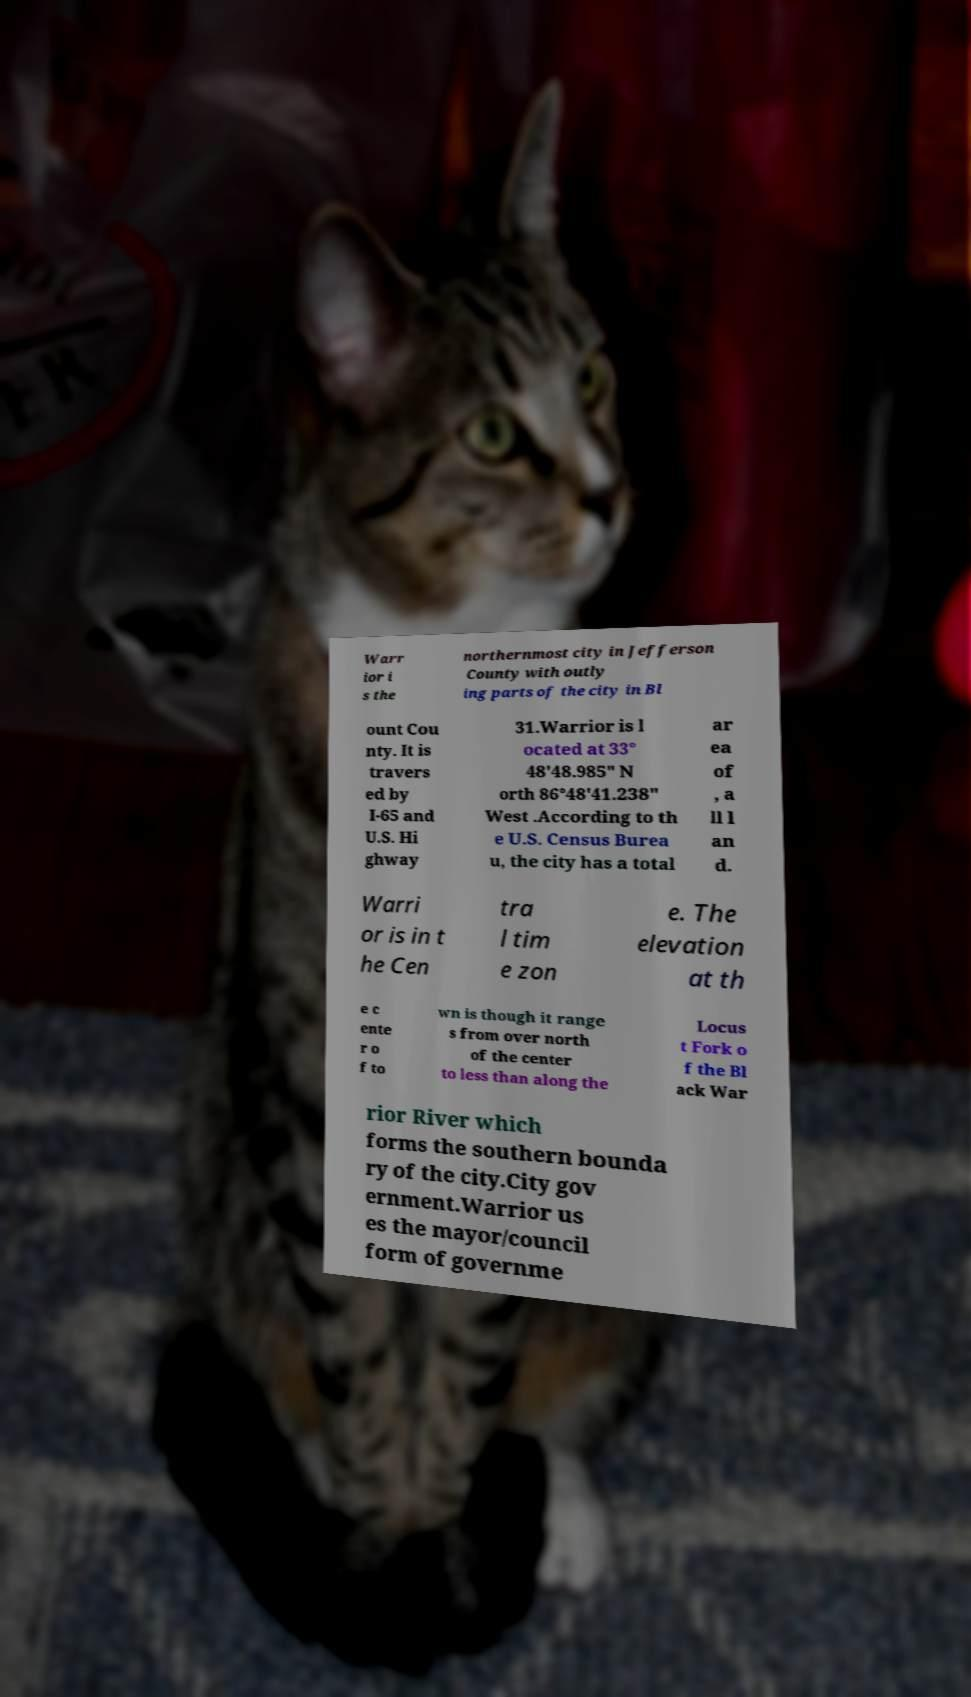I need the written content from this picture converted into text. Can you do that? Warr ior i s the northernmost city in Jefferson County with outly ing parts of the city in Bl ount Cou nty. It is travers ed by I-65 and U.S. Hi ghway 31.Warrior is l ocated at 33° 48'48.985" N orth 86°48'41.238" West .According to th e U.S. Census Burea u, the city has a total ar ea of , a ll l an d. Warri or is in t he Cen tra l tim e zon e. The elevation at th e c ente r o f to wn is though it range s from over north of the center to less than along the Locus t Fork o f the Bl ack War rior River which forms the southern bounda ry of the city.City gov ernment.Warrior us es the mayor/council form of governme 